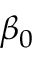Convert formula to latex. <formula><loc_0><loc_0><loc_500><loc_500>\beta _ { 0 }</formula> 